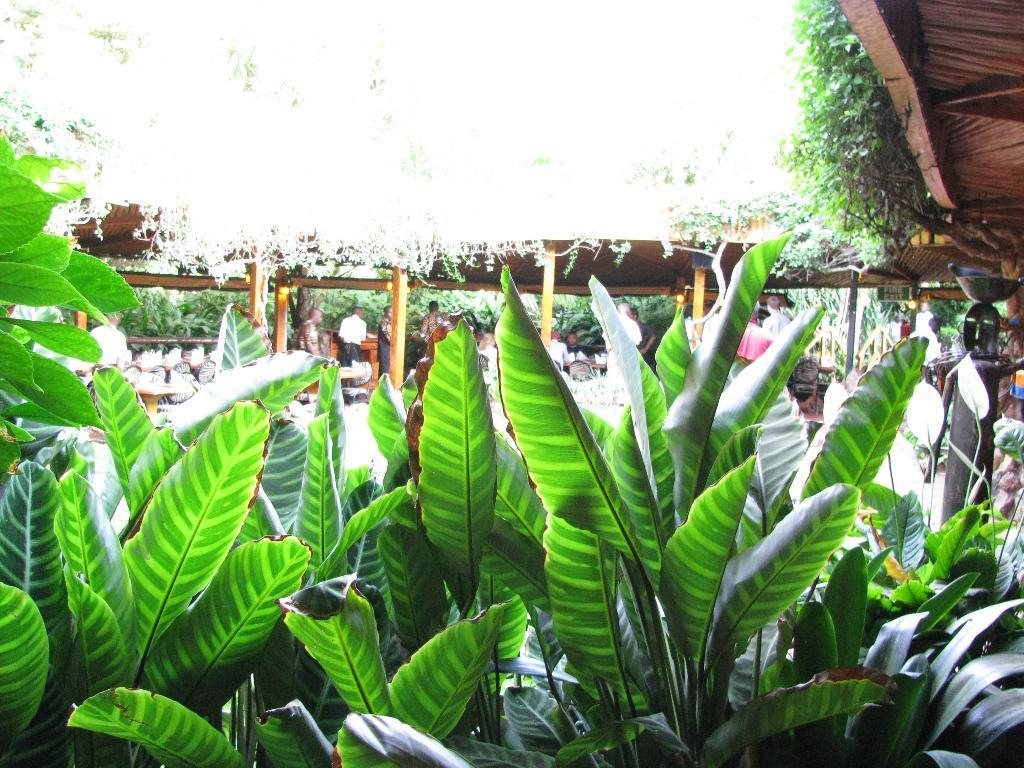Can you describe this image briefly? In this image in the foreground there are some plants, and in the background there are some persons, shed, pillars and some other objects. And on the right side there are some plants, and at the top of the image there is sky. 